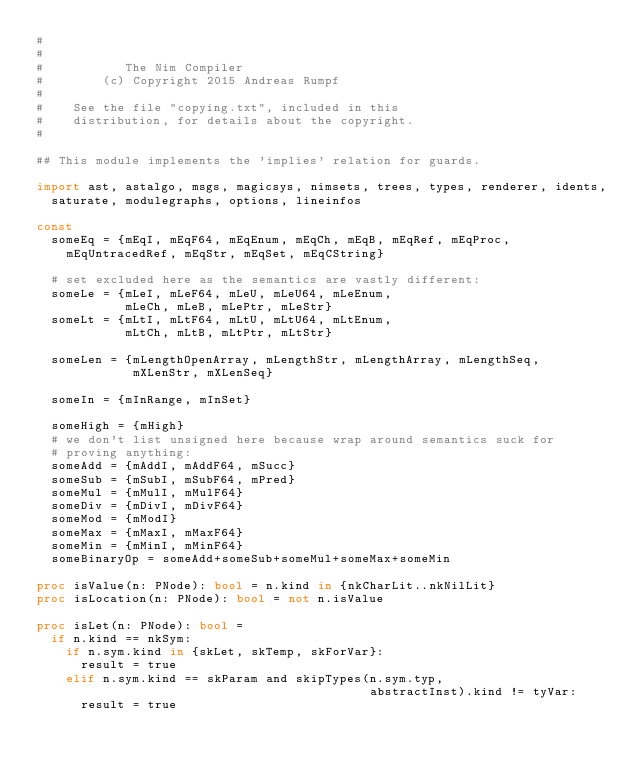<code> <loc_0><loc_0><loc_500><loc_500><_Nim_>#
#
#           The Nim Compiler
#        (c) Copyright 2015 Andreas Rumpf
#
#    See the file "copying.txt", included in this
#    distribution, for details about the copyright.
#

## This module implements the 'implies' relation for guards.

import ast, astalgo, msgs, magicsys, nimsets, trees, types, renderer, idents,
  saturate, modulegraphs, options, lineinfos

const
  someEq = {mEqI, mEqF64, mEqEnum, mEqCh, mEqB, mEqRef, mEqProc,
    mEqUntracedRef, mEqStr, mEqSet, mEqCString}

  # set excluded here as the semantics are vastly different:
  someLe = {mLeI, mLeF64, mLeU, mLeU64, mLeEnum,
            mLeCh, mLeB, mLePtr, mLeStr}
  someLt = {mLtI, mLtF64, mLtU, mLtU64, mLtEnum,
            mLtCh, mLtB, mLtPtr, mLtStr}

  someLen = {mLengthOpenArray, mLengthStr, mLengthArray, mLengthSeq,
             mXLenStr, mXLenSeq}

  someIn = {mInRange, mInSet}

  someHigh = {mHigh}
  # we don't list unsigned here because wrap around semantics suck for
  # proving anything:
  someAdd = {mAddI, mAddF64, mSucc}
  someSub = {mSubI, mSubF64, mPred}
  someMul = {mMulI, mMulF64}
  someDiv = {mDivI, mDivF64}
  someMod = {mModI}
  someMax = {mMaxI, mMaxF64}
  someMin = {mMinI, mMinF64}
  someBinaryOp = someAdd+someSub+someMul+someMax+someMin

proc isValue(n: PNode): bool = n.kind in {nkCharLit..nkNilLit}
proc isLocation(n: PNode): bool = not n.isValue

proc isLet(n: PNode): bool =
  if n.kind == nkSym:
    if n.sym.kind in {skLet, skTemp, skForVar}:
      result = true
    elif n.sym.kind == skParam and skipTypes(n.sym.typ,
                                             abstractInst).kind != tyVar:
      result = true
</code> 